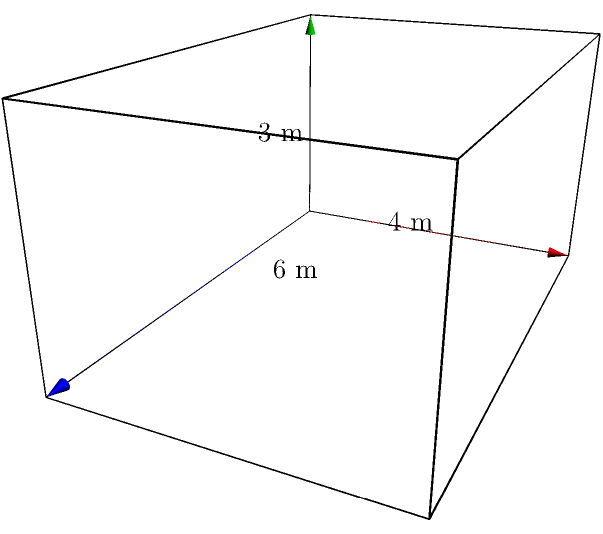A marketing research firm is designing a new display booth for a trade show. The booth is shaped like a rectangular prism with dimensions 6 m × 4 m × 3 m (length × width × height). To estimate material costs, they need to calculate the total surface area of the booth. What is the total surface area of the rectangular prism in square meters? To find the surface area of a rectangular prism, we need to calculate the area of each face and sum them up. Let's break it down step-by-step:

1. Identify the dimensions:
   Length (l) = 6 m
   Width (w) = 4 m
   Height (h) = 3 m

2. Calculate the areas of each pair of faces:
   - Front and back faces: $A_1 = 2(l \times h) = 2(6 \times 3) = 36$ m²
   - Left and right faces: $A_2 = 2(w \times h) = 2(4 \times 3) = 24$ m²
   - Top and bottom faces: $A_3 = 2(l \times w) = 2(6 \times 4) = 48$ m²

3. Sum up all the areas:
   Total Surface Area = $A_1 + A_2 + A_3 = 36 + 24 + 48 = 108$ m²

Therefore, the total surface area of the rectangular prism is 108 square meters.
Answer: 108 m² 